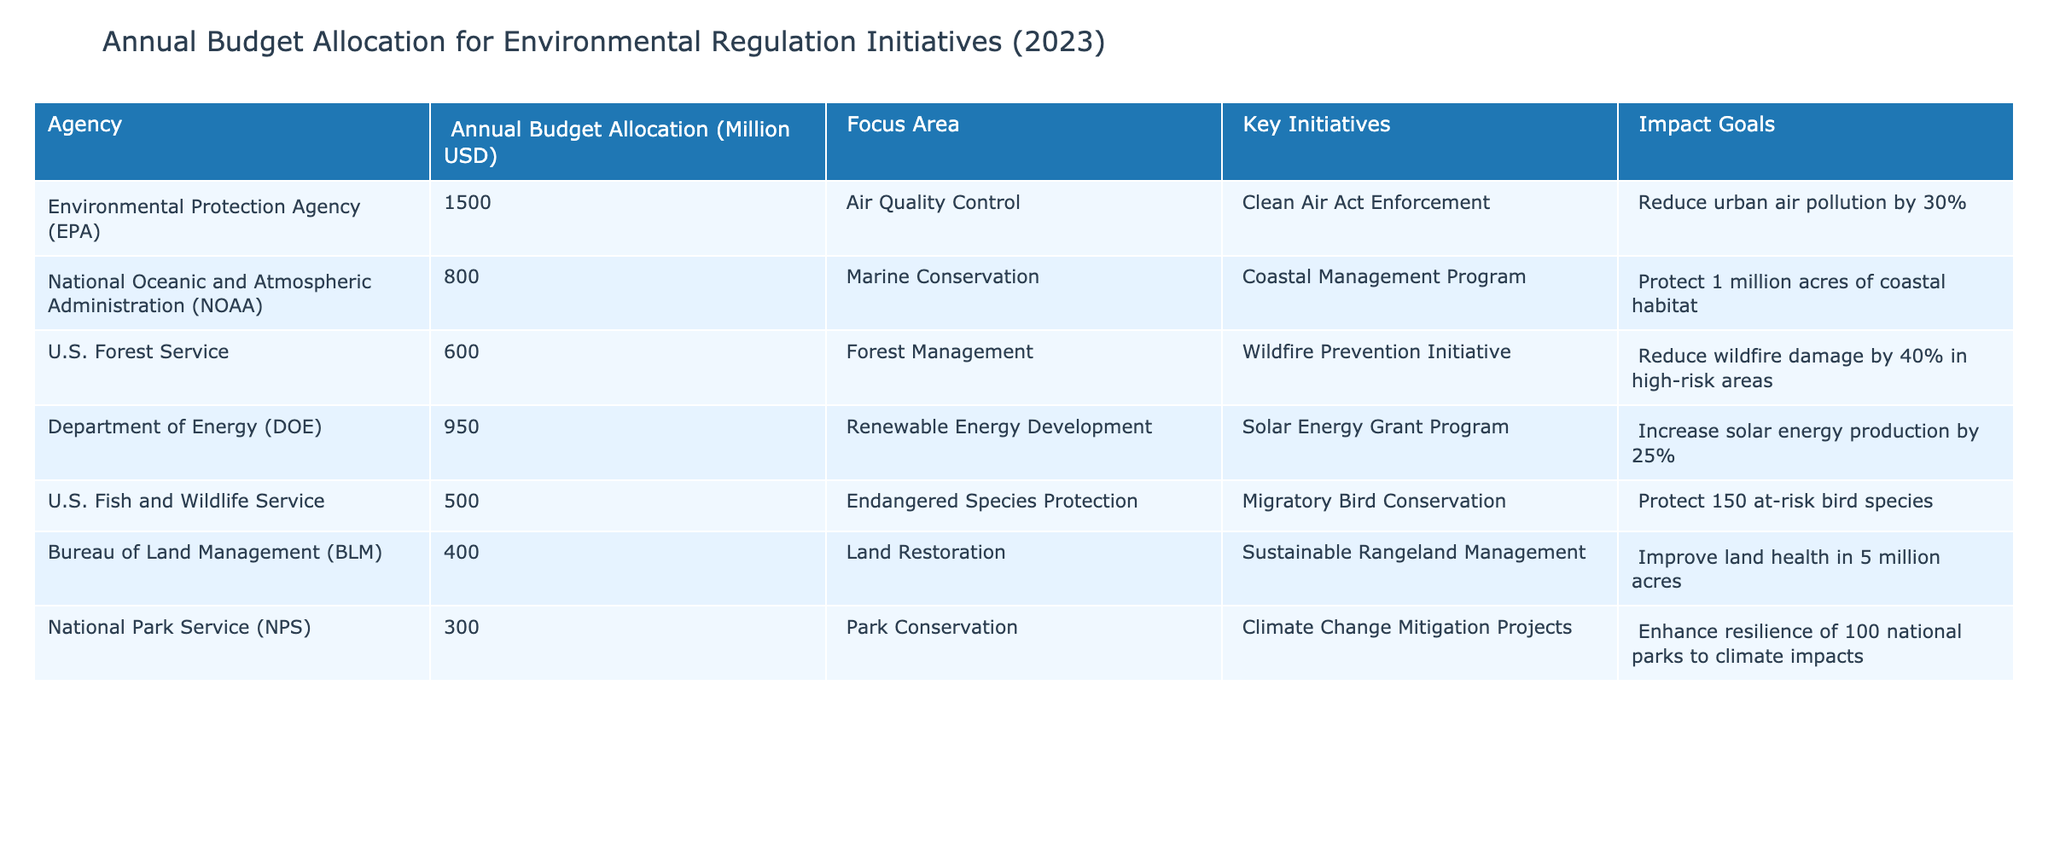What is the annual budget allocation of the Environmental Protection Agency (EPA)? From the table, the EPA's annual budget allocation is specifically listed under the respective column. It states, "1500" million USD.
Answer: 1500 million USD Which agency has the lowest annual budget allocation for environmental regulation initiatives? By examining the annual budget allocation figures for all agencies, the U.S. Fish and Wildlife Service has the lowest allocation of "500" million USD.
Answer: U.S. Fish and Wildlife Service What is the total annual budget allocation for all agencies listed in the table? A total can be calculated by summing the annual budget allocations: 1500 + 800 + 600 + 950 + 500 + 400 + 300 = 4050 million USD.
Answer: 4050 million USD Which agency focuses on marine conservation and what is its budget? The agency focused on marine conservation is the National Oceanic and Atmospheric Administration (NOAA), with an annual budget allocation of "800" million USD.
Answer: NOAA, 800 million USD What is the impact goal of the U.S. Forest Service's Wildfire Prevention Initiative? From the table, it is stated that the impact goal for the U.S. Forest Service's initiative is to "Reduce wildfire damage by 40% in high-risk areas."
Answer: Reduce wildfire damage by 40% If the Department of Energy (DOE) increases its budget by 10%, what will be the new allocation? The DOE's current allocation is "950" million USD. Increasing it by 10% means calculating 950 * 0.10 = 95, then adding that to the original amount: 950 + 95 = 1045 million USD.
Answer: 1045 million USD True or False: The National Park Service has an annual budget allocation greater than 400 million USD. The budget for the National Park Service is listed as "300" million USD, which is less than 400 million USD, making the statement false.
Answer: False What percentage of the total budget allocation is dedicated to the Department of Energy (DOE)? First, find the total allocation: 4050 million USD (calculated previously). The DOE's allocation is "950" million USD. Calculating the percentage: (950 / 4050) * 100 = 23.46%.
Answer: 23.46% Which agency is responsible for protecting endangered species, and what is its primary key initiative? The U.S. Fish and Wildlife Service is responsible for protecting endangered species, and its key initiative is "Migratory Bird Conservation."
Answer: U.S. Fish and Wildlife Service, Migratory Bird Conservation By how much does the annual budget allocation of the Bureau of Land Management (BLM) differ from that of the National Park Service (NPS)? BLM's allocation is "400" million USD and NPS's allocation is "300" million USD. Subtracting them gives: 400 - 300 = 100 million USD, indicating that BLM's budget is 100 million USD more.
Answer: 100 million USD Which focus area receives the highest annual budget allocation, and which agency is responsible for it? The focus area with the highest allocation is "Air Quality Control," managed by the Environmental Protection Agency (EPA) which receives "1500" million USD.
Answer: Air Quality Control, EPA 